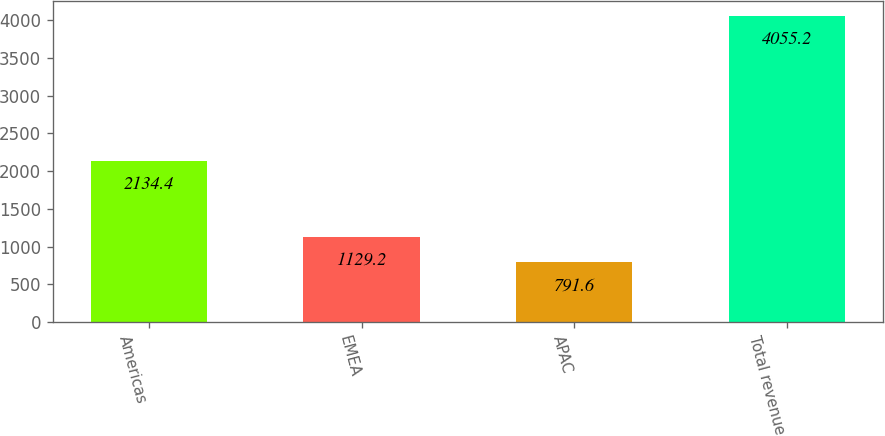<chart> <loc_0><loc_0><loc_500><loc_500><bar_chart><fcel>Americas<fcel>EMEA<fcel>APAC<fcel>Total revenue<nl><fcel>2134.4<fcel>1129.2<fcel>791.6<fcel>4055.2<nl></chart> 